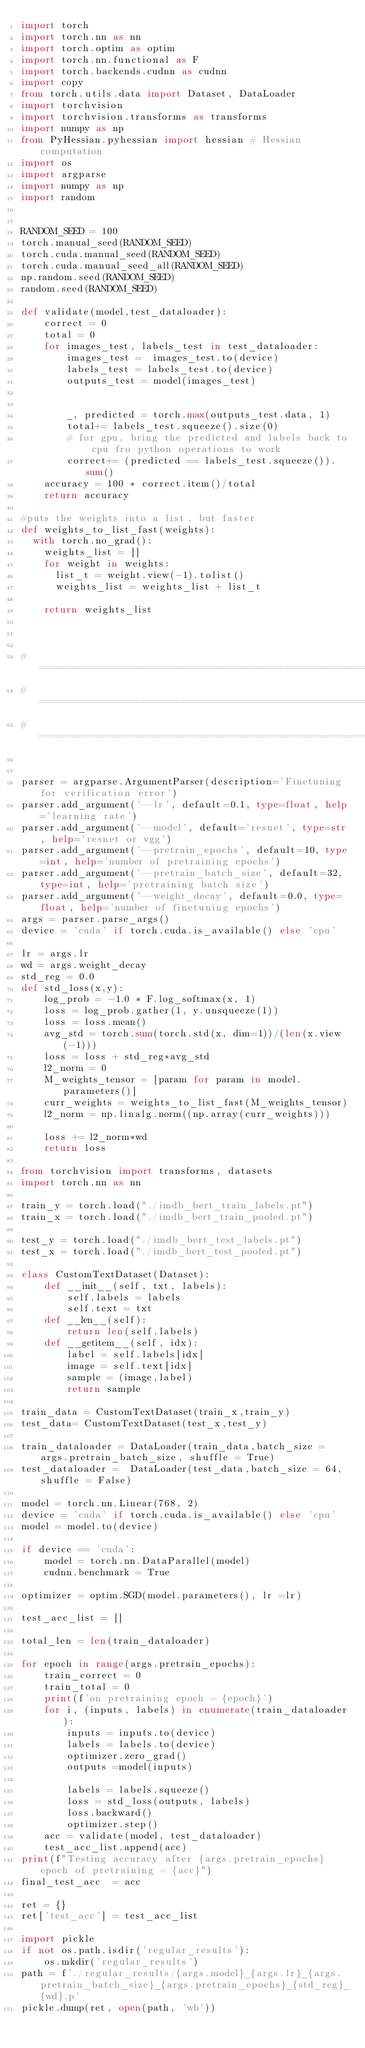Convert code to text. <code><loc_0><loc_0><loc_500><loc_500><_Python_>import torch
import torch.nn as nn
import torch.optim as optim
import torch.nn.functional as F
import torch.backends.cudnn as cudnn
import copy
from torch.utils.data import Dataset, DataLoader
import torchvision
import torchvision.transforms as transforms
import numpy as np
from PyHessian.pyhessian import hessian # Hessian computation
import os
import argparse
import numpy as np
import random 


RANDOM_SEED = 100
torch.manual_seed(RANDOM_SEED)
torch.cuda.manual_seed(RANDOM_SEED)
torch.cuda.manual_seed_all(RANDOM_SEED)
np.random.seed(RANDOM_SEED)
random.seed(RANDOM_SEED)

def validate(model,test_dataloader):
    correct = 0
    total = 0
    for images_test, labels_test in test_dataloader:
        images_test =  images_test.to(device)
        labels_test = labels_test.to(device)
        outputs_test = model(images_test)


        _, predicted = torch.max(outputs_test.data, 1)
        total+= labels_test.squeeze().size(0)
        # for gpu, bring the predicted and labels back to cpu fro python operations to work
        correct+= (predicted == labels_test.squeeze()).sum()
    accuracy = 100 * correct.item()/total
    return accuracy

#puts the weights into a list, but faster
def weights_to_list_fast(weights):
  with torch.no_grad():
    weights_list = []
    for weight in weights:
      list_t = weight.view(-1).tolist()
      weights_list = weights_list + list_t

    return weights_list



#=====================================================================
#=====================================================================
#=====================================================================


parser = argparse.ArgumentParser(description='Finetuning for verification error')
parser.add_argument('--lr', default=0.1, type=float, help='learning rate')
parser.add_argument('--model', default='resnet', type=str, help='resnet or vgg')
parser.add_argument('--pretrain_epochs', default=10, type=int, help='number of pretraining epochs')
parser.add_argument('--pretrain_batch_size', default=32, type=int, help='pretraining batch size')
parser.add_argument('--weight_decay', default=0.0, type=float, help='number of finetuning epochs')
args = parser.parse_args()
device = 'cuda' if torch.cuda.is_available() else 'cpu'

lr = args.lr
wd = args.weight_decay
std_reg = 0.0
def std_loss(x,y):
    log_prob = -1.0 * F.log_softmax(x, 1)
    loss = log_prob.gather(1, y.unsqueeze(1))
    loss = loss.mean()
    avg_std = torch.sum(torch.std(x, dim=1))/(len(x.view(-1)))
    loss = loss + std_reg*avg_std
    l2_norm = 0
    M_weights_tensor = [param for param in model.parameters()]
    curr_weights = weights_to_list_fast(M_weights_tensor)
    l2_norm = np.linalg.norm((np.array(curr_weights)))
    
    loss += l2_norm*wd
    return loss

from torchvision import transforms, datasets
import torch.nn as nn

train_y = torch.load("./imdb_bert_train_labels.pt")
train_x = torch.load("./imdb_bert_train_pooled.pt")

test_y = torch.load("./imdb_bert_test_labels.pt")
test_x = torch.load("./imdb_bert_test_pooled.pt")

class CustomTextDataset(Dataset):
    def __init__(self, txt, labels):
        self.labels = labels
        self.text = txt
    def __len__(self):
        return len(self.labels)
    def __getitem__(self, idx):
        label = self.labels[idx]
        image = self.text[idx]
        sample = (image,label)
        return sample

train_data = CustomTextDataset(train_x,train_y)
test_data= CustomTextDataset(test_x,test_y)

train_dataloader = DataLoader(train_data,batch_size = args.pretrain_batch_size, shuffle = True)
test_dataloader =  DataLoader(test_data,batch_size = 64, shuffle = False)

model = torch.nn.Linear(768, 2)
device = 'cuda' if torch.cuda.is_available() else 'cpu'
model = model.to(device)

if device == 'cuda':
    model = torch.nn.DataParallel(model)
    cudnn.benchmark = True

optimizer = optim.SGD(model.parameters(), lr =lr)

test_acc_list = []

total_len = len(train_dataloader)

for epoch in range(args.pretrain_epochs):
    train_correct = 0
    train_total = 0
    print(f'on pretraining epoch = {epoch}')
    for i, (inputs, labels) in enumerate(train_dataloader):
        inputs = inputs.to(device)
        labels = labels.to(device)
        optimizer.zero_grad()
        outputs =model(inputs)

        labels = labels.squeeze()
        loss = std_loss(outputs, labels)
        loss.backward()
        optimizer.step()
    acc = validate(model, test_dataloader)
    test_acc_list.append(acc) 
print(f"Testing accuracy after {args.pretrain_epochs} epoch of pretraining = {acc}")
final_test_acc  = acc

ret = {}
ret['test_acc'] = test_acc_list

import pickle
if not os.path.isdir('regular_results'):
    os.mkdir('regular_results')
path = f'./regular_results/{args.model}_{args.lr}_{args.pretrain_batch_size}_{args.pretrain_epochs}_{std_reg}_{wd}.p'
pickle.dump(ret, open(path, 'wb'))






</code> 